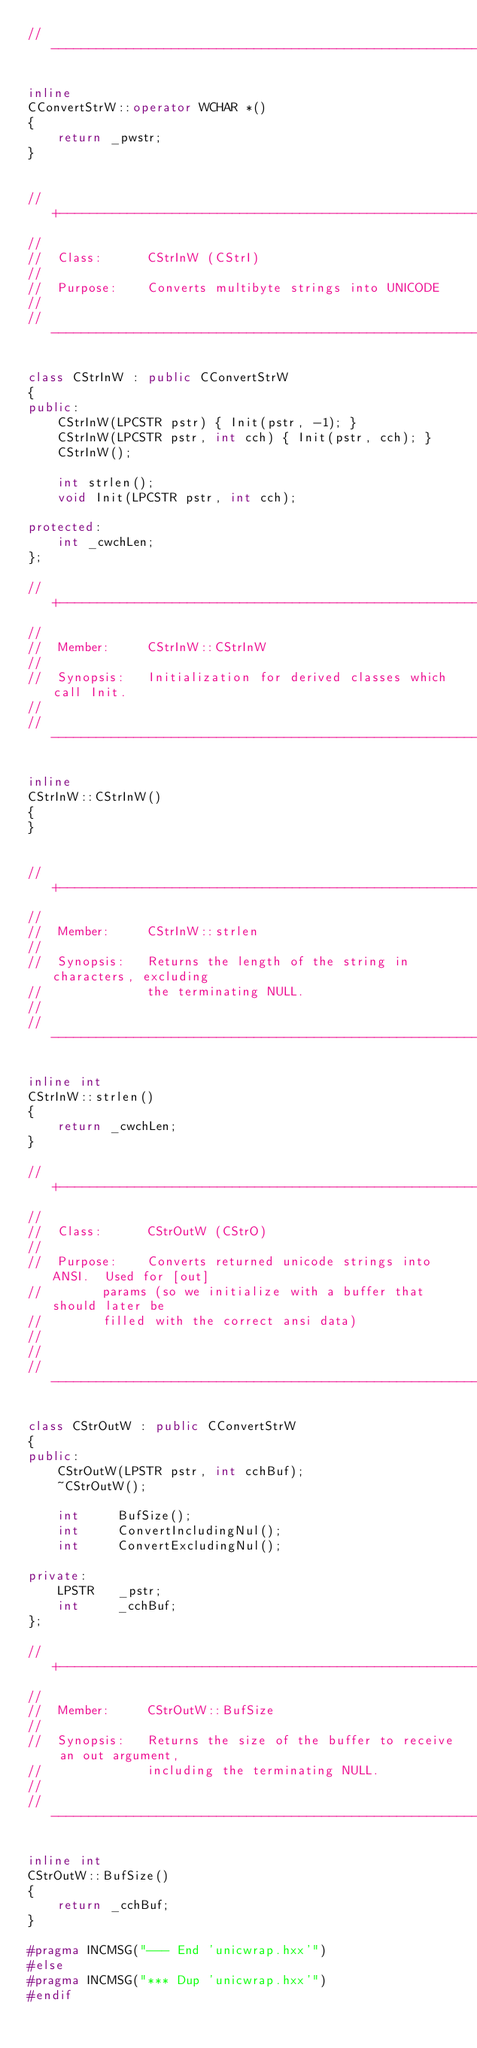Convert code to text. <code><loc_0><loc_0><loc_500><loc_500><_C++_>//----------------------------------------------------------------------------

inline 
CConvertStrW::operator WCHAR *()
{
    return _pwstr;
}


//+---------------------------------------------------------------------------
//
//  Class:      CStrInW (CStrI)
//
//  Purpose:    Converts multibyte strings into UNICODE
//
//----------------------------------------------------------------------------

class CStrInW : public CConvertStrW
{
public:
    CStrInW(LPCSTR pstr) { Init(pstr, -1); }
    CStrInW(LPCSTR pstr, int cch) { Init(pstr, cch); }
    CStrInW();

    int strlen();
    void Init(LPCSTR pstr, int cch);

protected:
    int _cwchLen;
};

//+---------------------------------------------------------------------------
//
//  Member:     CStrInW::CStrInW
//
//  Synopsis:   Initialization for derived classes which call Init.
//
//----------------------------------------------------------------------------

inline
CStrInW::CStrInW()
{
}


//+---------------------------------------------------------------------------
//
//  Member:     CStrInW::strlen
//
//  Synopsis:   Returns the length of the string in characters, excluding
//              the terminating NULL.
//
//----------------------------------------------------------------------------

inline int
CStrInW::strlen()
{
    return _cwchLen;
}

//+---------------------------------------------------------------------------
//
//  Class:      CStrOutW (CStrO)
//
//  Purpose:    Converts returned unicode strings into ANSI.  Used for [out]
//				params (so we initialize with a buffer that should later be
//				filled with the correct ansi data)
//			
//
//----------------------------------------------------------------------------

class CStrOutW : public CConvertStrW
{
public:
    CStrOutW(LPSTR pstr, int cchBuf);
    ~CStrOutW();

    int     BufSize();
    int     ConvertIncludingNul();
    int     ConvertExcludingNul();

private:
    LPSTR  	_pstr;
    int     _cchBuf;
};

//+---------------------------------------------------------------------------
//
//  Member:     CStrOutW::BufSize
//
//  Synopsis:   Returns the size of the buffer to receive an out argument,
//              including the terminating NULL.
//
//----------------------------------------------------------------------------

inline int
CStrOutW::BufSize()
{
    return _cchBuf;
}

#pragma INCMSG("--- End 'unicwrap.hxx'")
#else
#pragma INCMSG("*** Dup 'unicwrap.hxx'")
#endif
</code> 